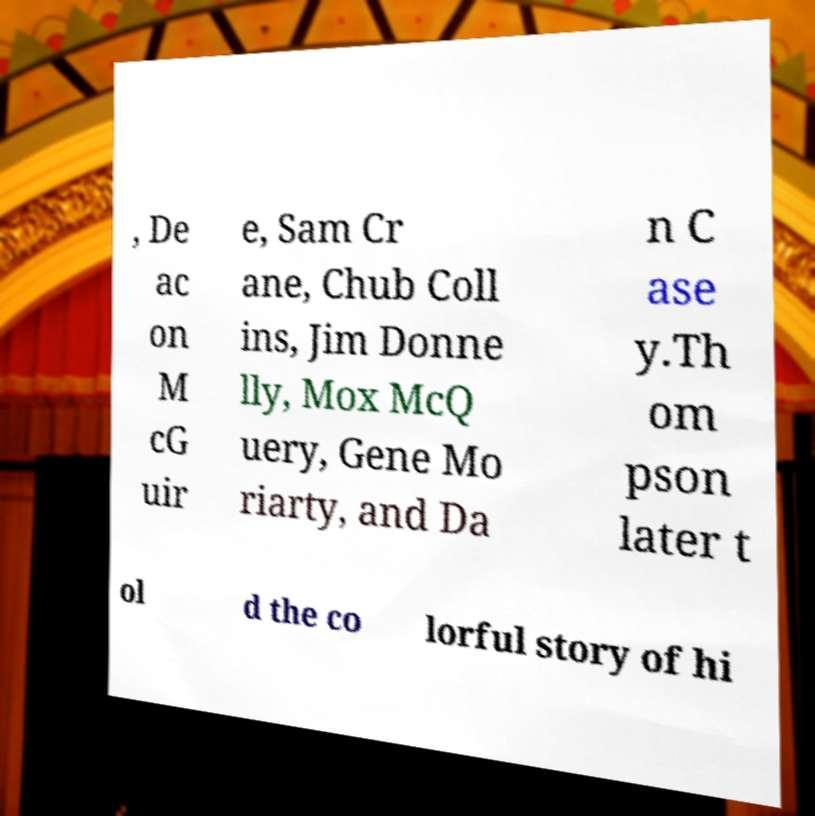Could you extract and type out the text from this image? , De ac on M cG uir e, Sam Cr ane, Chub Coll ins, Jim Donne lly, Mox McQ uery, Gene Mo riarty, and Da n C ase y.Th om pson later t ol d the co lorful story of hi 